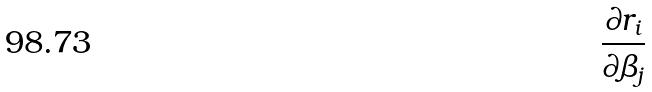<formula> <loc_0><loc_0><loc_500><loc_500>\frac { \partial r _ { i } } { \partial \beta _ { j } }</formula> 